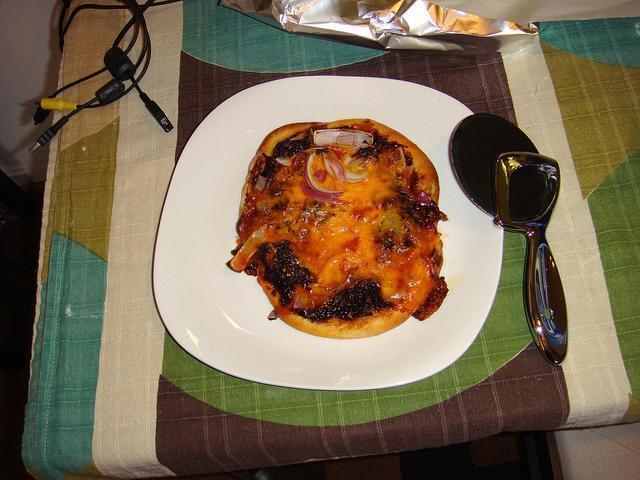How many people are wearing a red shirt?
Give a very brief answer. 0. 